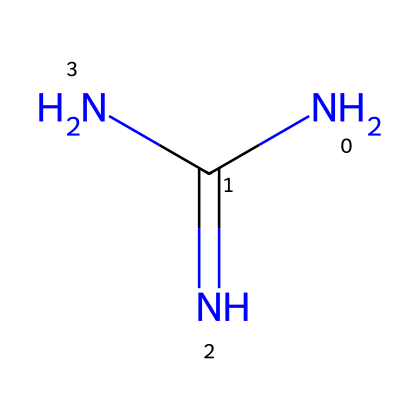What is the chemical name of the structure represented by this SMILES? The SMILES notation "NC(=N)N" represents guanidine, as the functional groups and arrangement correspond to that specific compound.
Answer: guanidine How many nitrogen atoms are present in guanidine? The SMILES shows three nitrogen atoms (N) are connected to the central carbon atom with two of them being part of the imine group, indicating there are a total of three nitrogen atoms in guanidine.
Answer: three What type of bonds are present in guanidine? Looking at the SMILES, there is one double bond (C=) and the rest are single bonds connecting the nitrogen atoms and the carbon, which identifies the presence of both single and double bonds in guanidine.
Answer: single and double What is the hybridization state of the carbon atom in guanidine? The carbon in guanidine is connected to three nitrogen atoms (one via a double bond and two via single bonds), indicating it is sp² hybridized due to having one double bond and a trigonal planar arrangement.
Answer: sp² How does guanidine behave in basic conditions? Guanidine acts as a strong base in an aqueous solution due to the presence of multiple nitrogen atoms which have lone pairs, allowing it to accept protons readily.
Answer: strong base What type of chemical reaction can guanidine undergo due to its structure? Guanidine can participate in nucleophilic reactions because its nitrogen atoms have lone pairs that can attack electrophiles, making it valuable in various organic reactions.
Answer: nucleophilic reaction What increases the solubility of guanidine in water? The presence of multiple polar nitrogen atoms with lone pairs, which can interact with water molecules via hydrogen bonding, significantly increases its solubility in water.
Answer: hydrogen bonding 